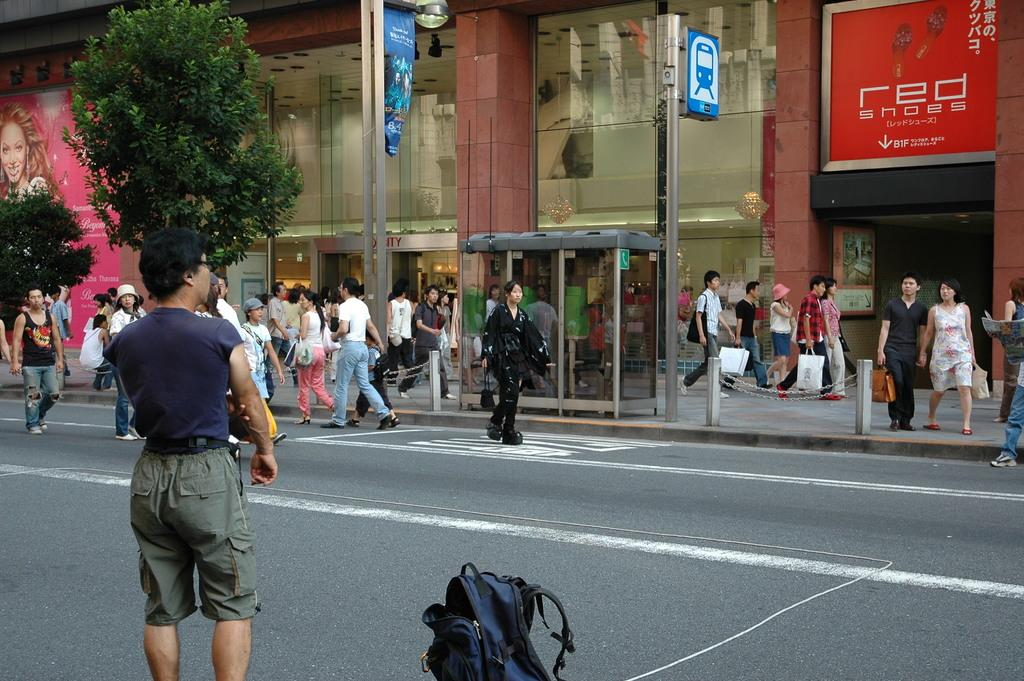What are the people in the image doing? The people in the image are standing on the road. What can be seen in the background of the image? There is a building and trees visible in the background of the image. What type of toy can be seen being traded between the people in the image? There is no toy present in the image, nor is there any indication of trading between the people. 